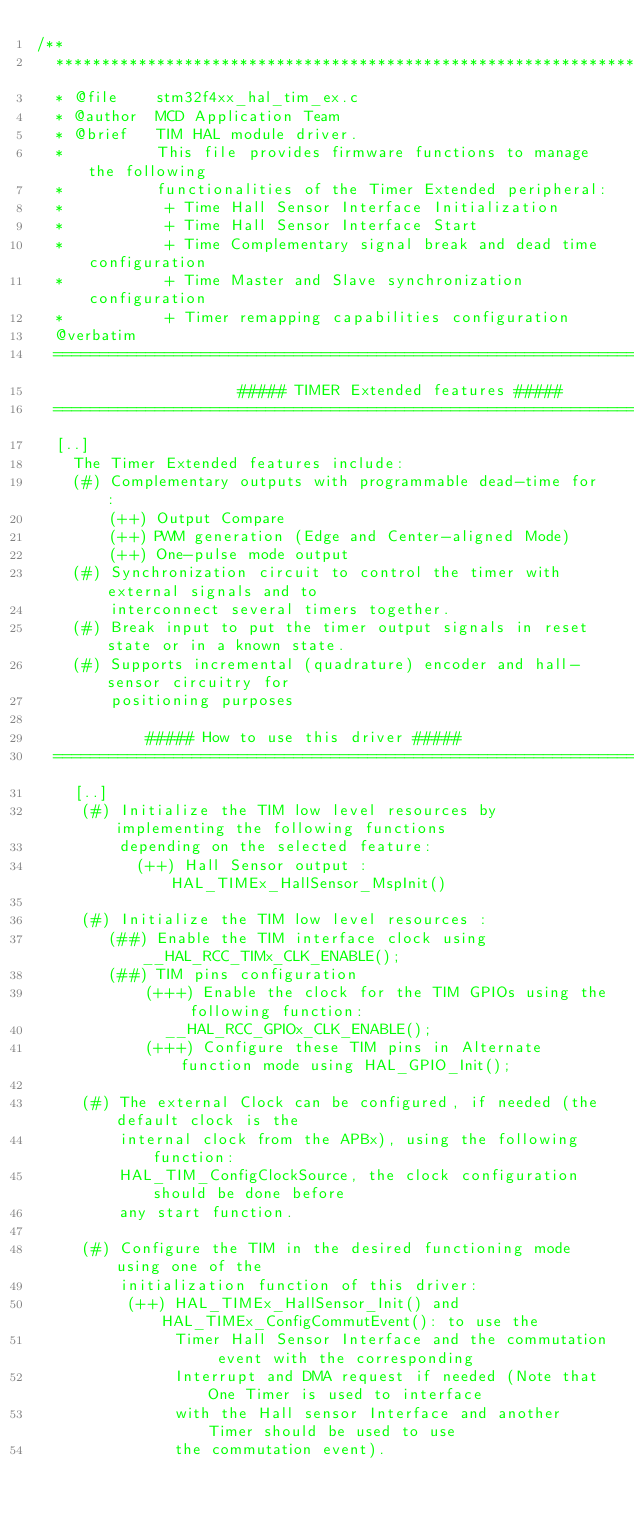<code> <loc_0><loc_0><loc_500><loc_500><_C_>/**
  ******************************************************************************
  * @file    stm32f4xx_hal_tim_ex.c
  * @author  MCD Application Team
  * @brief   TIM HAL module driver.
  *          This file provides firmware functions to manage the following
  *          functionalities of the Timer Extended peripheral:
  *           + Time Hall Sensor Interface Initialization
  *           + Time Hall Sensor Interface Start
  *           + Time Complementary signal break and dead time configuration
  *           + Time Master and Slave synchronization configuration
  *           + Timer remapping capabilities configuration
  @verbatim
  ==============================================================================
                      ##### TIMER Extended features #####
  ==============================================================================
  [..]
    The Timer Extended features include:
    (#) Complementary outputs with programmable dead-time for :
        (++) Output Compare
        (++) PWM generation (Edge and Center-aligned Mode)
        (++) One-pulse mode output
    (#) Synchronization circuit to control the timer with external signals and to
        interconnect several timers together.
    (#) Break input to put the timer output signals in reset state or in a known state.
    (#) Supports incremental (quadrature) encoder and hall-sensor circuitry for
        positioning purposes

            ##### How to use this driver #####
  ==============================================================================
    [..]
     (#) Initialize the TIM low level resources by implementing the following functions
         depending on the selected feature:
           (++) Hall Sensor output : HAL_TIMEx_HallSensor_MspInit()

     (#) Initialize the TIM low level resources :
        (##) Enable the TIM interface clock using __HAL_RCC_TIMx_CLK_ENABLE();
        (##) TIM pins configuration
            (+++) Enable the clock for the TIM GPIOs using the following function:
              __HAL_RCC_GPIOx_CLK_ENABLE();
            (+++) Configure these TIM pins in Alternate function mode using HAL_GPIO_Init();

     (#) The external Clock can be configured, if needed (the default clock is the
         internal clock from the APBx), using the following function:
         HAL_TIM_ConfigClockSource, the clock configuration should be done before
         any start function.

     (#) Configure the TIM in the desired functioning mode using one of the
         initialization function of this driver:
          (++) HAL_TIMEx_HallSensor_Init() and HAL_TIMEx_ConfigCommutEvent(): to use the
               Timer Hall Sensor Interface and the commutation event with the corresponding
               Interrupt and DMA request if needed (Note that One Timer is used to interface
               with the Hall sensor Interface and another Timer should be used to use
               the commutation event).</code> 